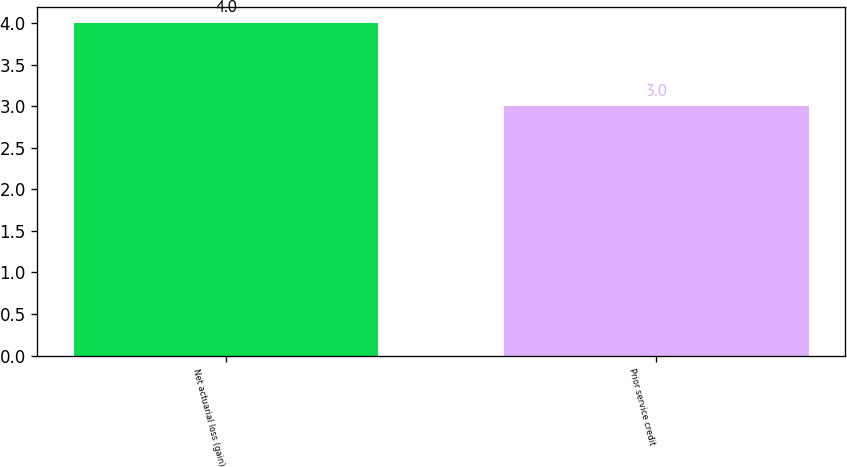Convert chart. <chart><loc_0><loc_0><loc_500><loc_500><bar_chart><fcel>Net actuarial loss (gain)<fcel>Prior service credit<nl><fcel>4<fcel>3<nl></chart> 